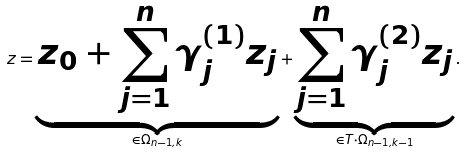Convert formula to latex. <formula><loc_0><loc_0><loc_500><loc_500>z = \underbrace { z _ { 0 } + \sum _ { j = 1 } ^ { n } \gamma _ { j } ^ { ( 1 ) } z _ { j } } _ { \in \Omega _ { n - 1 , k } } + \underbrace { \sum _ { j = 1 } ^ { n } \gamma _ { j } ^ { ( 2 ) } z _ { j } } _ { \in T \cdot \Omega _ { n - 1 , k - 1 } } .</formula> 